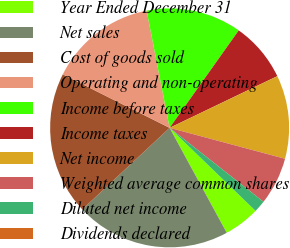Convert chart. <chart><loc_0><loc_0><loc_500><loc_500><pie_chart><fcel>Year Ended December 31<fcel>Net sales<fcel>Cost of goods sold<fcel>Operating and non-operating<fcel>Income before taxes<fcel>Income taxes<fcel>Net income<fcel>Weighted average common shares<fcel>Diluted net income<fcel>Dividends declared<nl><fcel>4.84%<fcel>20.97%<fcel>19.35%<fcel>14.52%<fcel>12.9%<fcel>8.06%<fcel>11.29%<fcel>6.45%<fcel>1.61%<fcel>0.0%<nl></chart> 